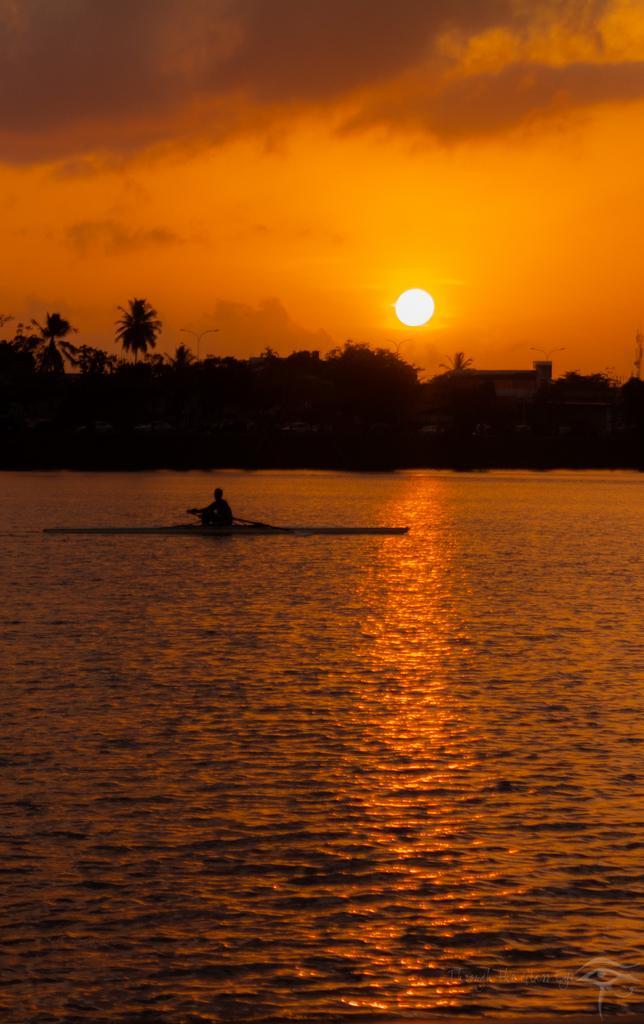Could you give a brief overview of what you see in this image? This image is taken outdoors. At the bottom of the image there is a river with water. At the top of the image there is a sky with clouds and sun. In the background there are a few trees. In the middle of the image a person is sailing on the river with a boat. 